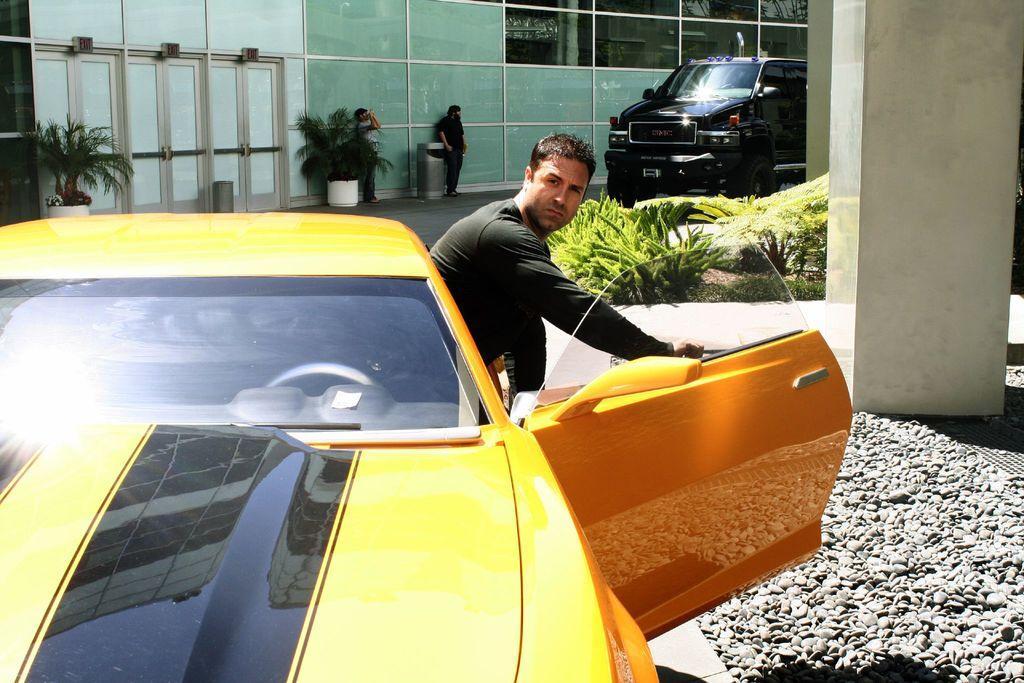Please provide a concise description of this image. In this image there are three person. In front the person is coming out from the car. At the background we can see a building and a glass door. There is a flower pot on the floor. 